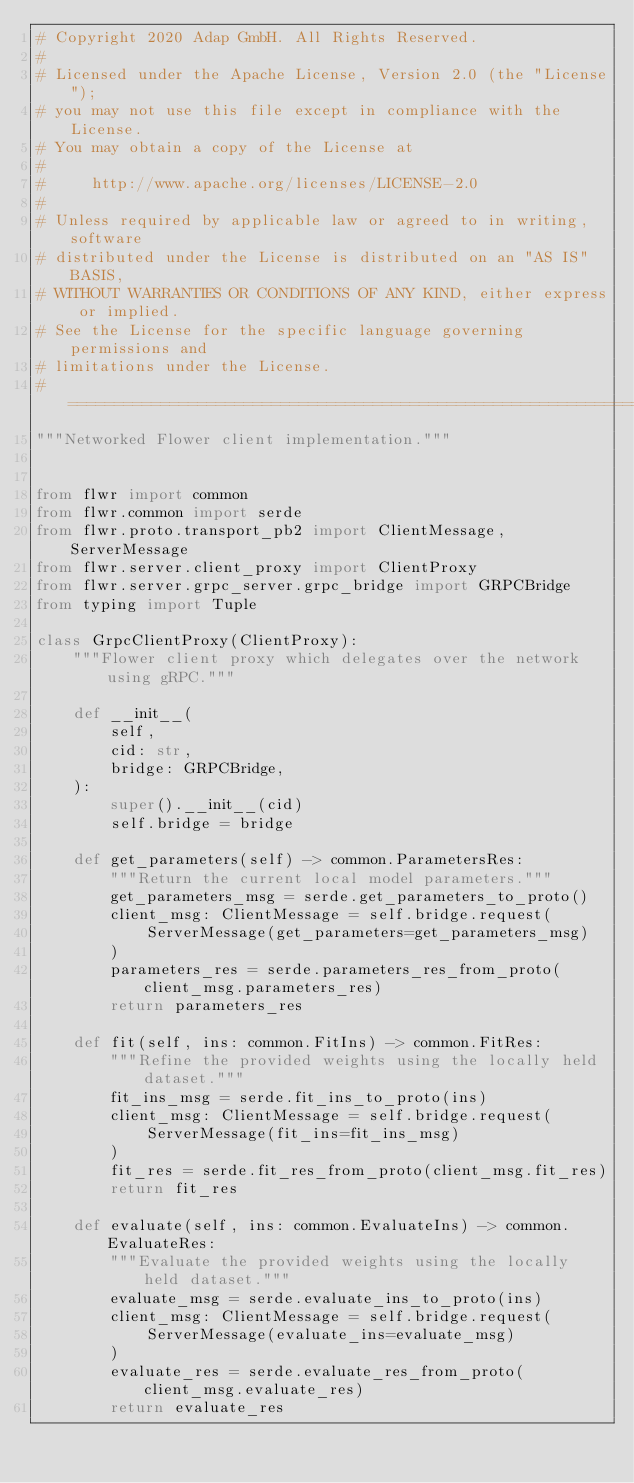<code> <loc_0><loc_0><loc_500><loc_500><_Python_># Copyright 2020 Adap GmbH. All Rights Reserved.
#
# Licensed under the Apache License, Version 2.0 (the "License");
# you may not use this file except in compliance with the License.
# You may obtain a copy of the License at
#
#     http://www.apache.org/licenses/LICENSE-2.0
#
# Unless required by applicable law or agreed to in writing, software
# distributed under the License is distributed on an "AS IS" BASIS,
# WITHOUT WARRANTIES OR CONDITIONS OF ANY KIND, either express or implied.
# See the License for the specific language governing permissions and
# limitations under the License.
# ==============================================================================
"""Networked Flower client implementation."""


from flwr import common
from flwr.common import serde
from flwr.proto.transport_pb2 import ClientMessage, ServerMessage
from flwr.server.client_proxy import ClientProxy
from flwr.server.grpc_server.grpc_bridge import GRPCBridge
from typing import Tuple

class GrpcClientProxy(ClientProxy):
    """Flower client proxy which delegates over the network using gRPC."""

    def __init__(
        self,
        cid: str,
        bridge: GRPCBridge,
    ):
        super().__init__(cid)
        self.bridge = bridge

    def get_parameters(self) -> common.ParametersRes:
        """Return the current local model parameters."""
        get_parameters_msg = serde.get_parameters_to_proto()
        client_msg: ClientMessage = self.bridge.request(
            ServerMessage(get_parameters=get_parameters_msg)
        )
        parameters_res = serde.parameters_res_from_proto(client_msg.parameters_res)
        return parameters_res

    def fit(self, ins: common.FitIns) -> common.FitRes:
        """Refine the provided weights using the locally held dataset."""
        fit_ins_msg = serde.fit_ins_to_proto(ins)
        client_msg: ClientMessage = self.bridge.request(
            ServerMessage(fit_ins=fit_ins_msg)
        )
        fit_res = serde.fit_res_from_proto(client_msg.fit_res)
        return fit_res

    def evaluate(self, ins: common.EvaluateIns) -> common.EvaluateRes:
        """Evaluate the provided weights using the locally held dataset."""
        evaluate_msg = serde.evaluate_ins_to_proto(ins)
        client_msg: ClientMessage = self.bridge.request(
            ServerMessage(evaluate_ins=evaluate_msg)
        )
        evaluate_res = serde.evaluate_res_from_proto(client_msg.evaluate_res)
        return evaluate_res
</code> 